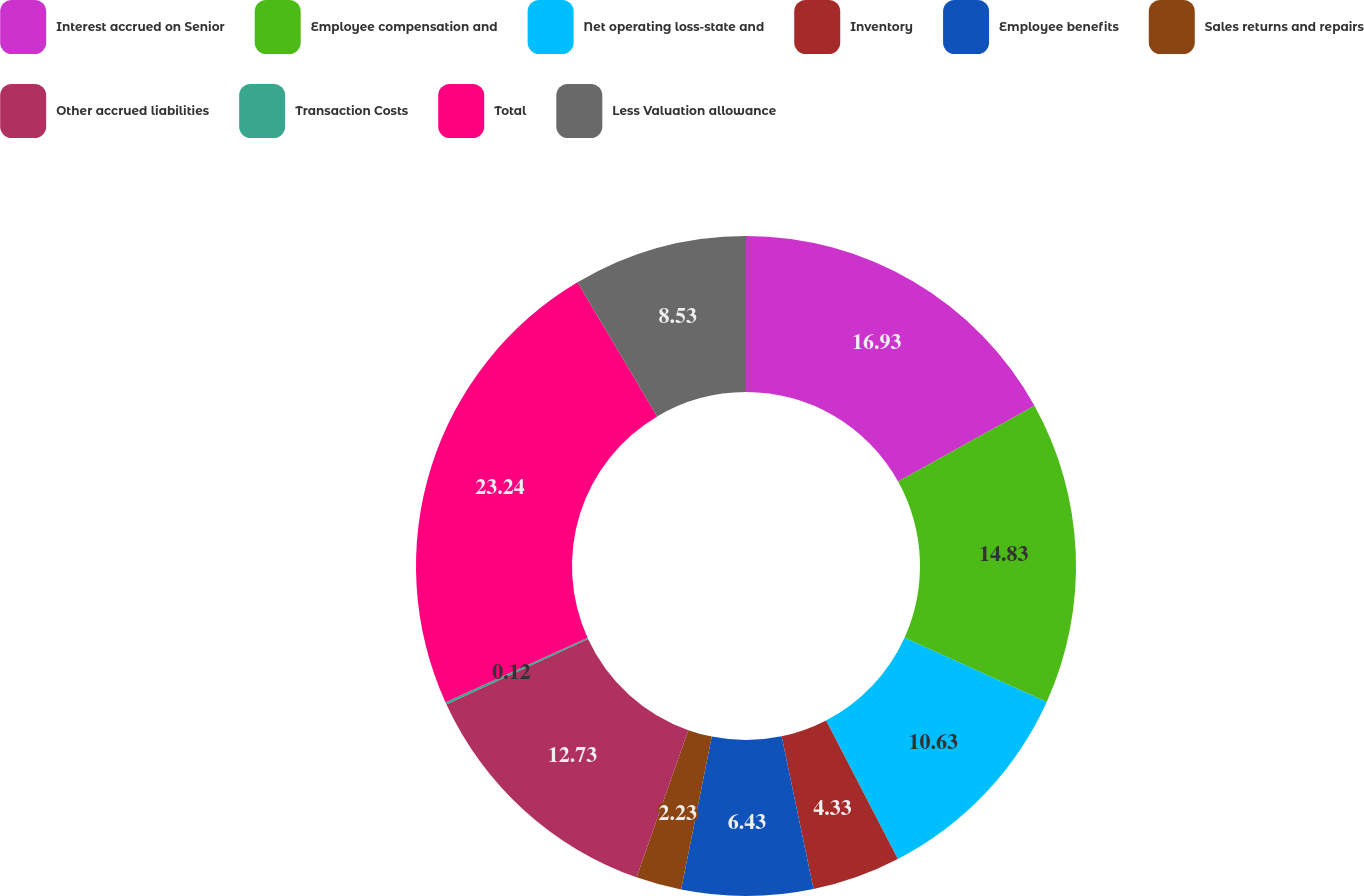Convert chart to OTSL. <chart><loc_0><loc_0><loc_500><loc_500><pie_chart><fcel>Interest accrued on Senior<fcel>Employee compensation and<fcel>Net operating loss-state and<fcel>Inventory<fcel>Employee benefits<fcel>Sales returns and repairs<fcel>Other accrued liabilities<fcel>Transaction Costs<fcel>Total<fcel>Less Valuation allowance<nl><fcel>16.93%<fcel>14.83%<fcel>10.63%<fcel>4.33%<fcel>6.43%<fcel>2.23%<fcel>12.73%<fcel>0.12%<fcel>23.24%<fcel>8.53%<nl></chart> 